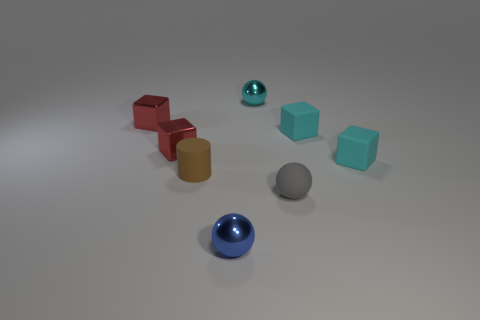What colors can you identify among the objects? There are several distinct colors present: red, brown, cyan, blue, and gray. Each color adds to the variety and visual interest of the setup. 